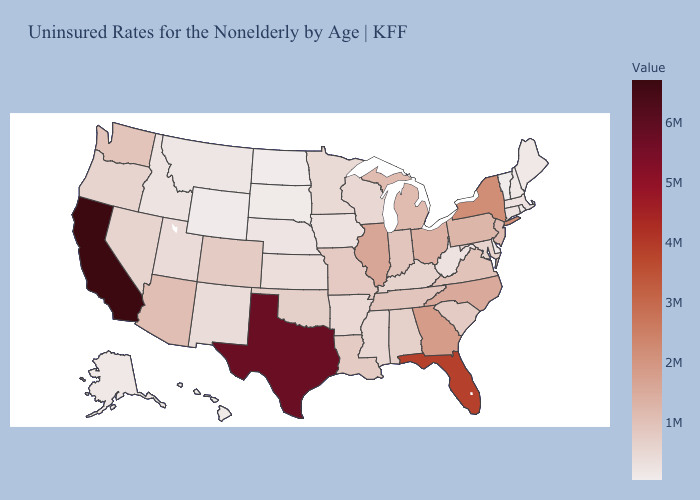Does California have the highest value in the USA?
Short answer required. Yes. Does the map have missing data?
Keep it brief. No. Is the legend a continuous bar?
Answer briefly. Yes. Among the states that border Colorado , does Nebraska have the lowest value?
Short answer required. No. Among the states that border Arkansas , which have the lowest value?
Give a very brief answer. Mississippi. Among the states that border Nevada , does Utah have the highest value?
Quick response, please. No. Among the states that border Vermont , which have the lowest value?
Quick response, please. New Hampshire. Is the legend a continuous bar?
Quick response, please. Yes. 